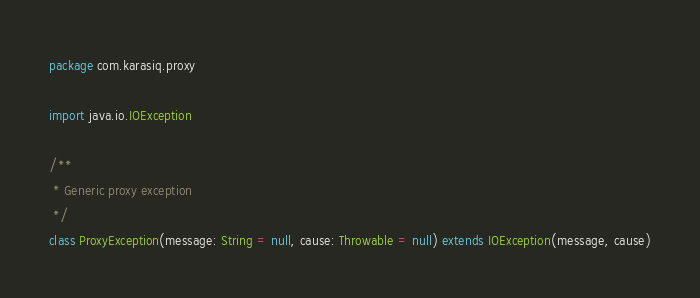<code> <loc_0><loc_0><loc_500><loc_500><_Scala_>package com.karasiq.proxy

import java.io.IOException

/**
 * Generic proxy exception
 */
class ProxyException(message: String = null, cause: Throwable = null) extends IOException(message, cause)
</code> 